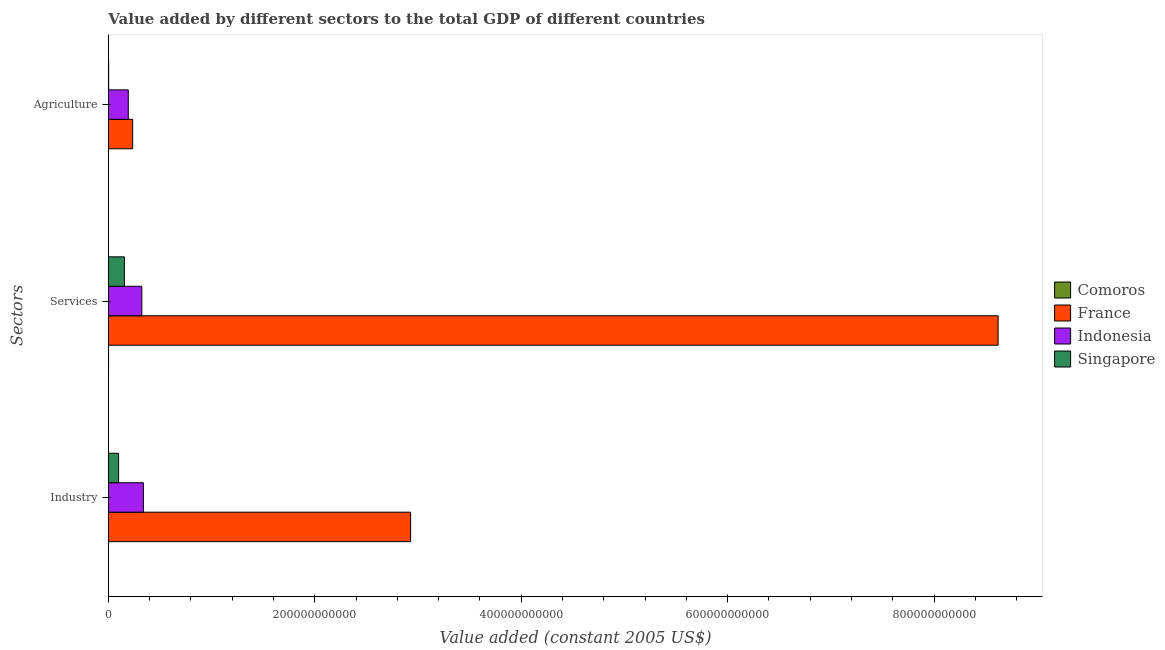How many different coloured bars are there?
Offer a very short reply. 4. Are the number of bars per tick equal to the number of legend labels?
Your response must be concise. Yes. What is the label of the 3rd group of bars from the top?
Provide a short and direct response. Industry. What is the value added by services in Indonesia?
Your answer should be very brief. 3.24e+1. Across all countries, what is the maximum value added by services?
Give a very brief answer. 8.62e+11. Across all countries, what is the minimum value added by industrial sector?
Provide a short and direct response. 3.03e+07. In which country was the value added by agricultural sector maximum?
Offer a very short reply. France. In which country was the value added by agricultural sector minimum?
Keep it short and to the point. Comoros. What is the total value added by industrial sector in the graph?
Provide a short and direct response. 3.37e+11. What is the difference between the value added by industrial sector in Indonesia and that in France?
Offer a terse response. -2.59e+11. What is the difference between the value added by industrial sector in Comoros and the value added by agricultural sector in Indonesia?
Your response must be concise. -1.92e+1. What is the average value added by industrial sector per country?
Provide a succinct answer. 8.41e+1. What is the difference between the value added by services and value added by industrial sector in Indonesia?
Your answer should be very brief. -1.52e+09. In how many countries, is the value added by services greater than 600000000000 US$?
Provide a succinct answer. 1. What is the ratio of the value added by agricultural sector in Indonesia to that in Comoros?
Provide a succinct answer. 274.52. Is the value added by agricultural sector in France less than that in Singapore?
Your answer should be compact. No. What is the difference between the highest and the second highest value added by industrial sector?
Offer a very short reply. 2.59e+11. What is the difference between the highest and the lowest value added by industrial sector?
Provide a succinct answer. 2.93e+11. In how many countries, is the value added by industrial sector greater than the average value added by industrial sector taken over all countries?
Your answer should be very brief. 1. What does the 4th bar from the top in Agriculture represents?
Ensure brevity in your answer.  Comoros. Is it the case that in every country, the sum of the value added by industrial sector and value added by services is greater than the value added by agricultural sector?
Your answer should be compact. Yes. How many bars are there?
Provide a succinct answer. 12. Are all the bars in the graph horizontal?
Your answer should be compact. Yes. How many countries are there in the graph?
Give a very brief answer. 4. What is the difference between two consecutive major ticks on the X-axis?
Offer a very short reply. 2.00e+11. Are the values on the major ticks of X-axis written in scientific E-notation?
Your response must be concise. No. Does the graph contain any zero values?
Offer a very short reply. No. How many legend labels are there?
Offer a very short reply. 4. How are the legend labels stacked?
Make the answer very short. Vertical. What is the title of the graph?
Your answer should be compact. Value added by different sectors to the total GDP of different countries. Does "Kuwait" appear as one of the legend labels in the graph?
Keep it short and to the point. No. What is the label or title of the X-axis?
Your response must be concise. Value added (constant 2005 US$). What is the label or title of the Y-axis?
Keep it short and to the point. Sectors. What is the Value added (constant 2005 US$) of Comoros in Industry?
Provide a succinct answer. 3.03e+07. What is the Value added (constant 2005 US$) of France in Industry?
Your answer should be compact. 2.93e+11. What is the Value added (constant 2005 US$) in Indonesia in Industry?
Your answer should be very brief. 3.39e+1. What is the Value added (constant 2005 US$) in Singapore in Industry?
Keep it short and to the point. 9.84e+09. What is the Value added (constant 2005 US$) of Comoros in Services?
Your answer should be very brief. 1.21e+08. What is the Value added (constant 2005 US$) in France in Services?
Your response must be concise. 8.62e+11. What is the Value added (constant 2005 US$) of Indonesia in Services?
Your answer should be compact. 3.24e+1. What is the Value added (constant 2005 US$) in Singapore in Services?
Your response must be concise. 1.54e+1. What is the Value added (constant 2005 US$) in Comoros in Agriculture?
Your answer should be very brief. 7.01e+07. What is the Value added (constant 2005 US$) of France in Agriculture?
Your answer should be very brief. 2.35e+1. What is the Value added (constant 2005 US$) in Indonesia in Agriculture?
Your answer should be compact. 1.92e+1. What is the Value added (constant 2005 US$) of Singapore in Agriculture?
Give a very brief answer. 2.40e+08. Across all Sectors, what is the maximum Value added (constant 2005 US$) of Comoros?
Offer a very short reply. 1.21e+08. Across all Sectors, what is the maximum Value added (constant 2005 US$) of France?
Your answer should be compact. 8.62e+11. Across all Sectors, what is the maximum Value added (constant 2005 US$) in Indonesia?
Provide a succinct answer. 3.39e+1. Across all Sectors, what is the maximum Value added (constant 2005 US$) of Singapore?
Provide a short and direct response. 1.54e+1. Across all Sectors, what is the minimum Value added (constant 2005 US$) of Comoros?
Give a very brief answer. 3.03e+07. Across all Sectors, what is the minimum Value added (constant 2005 US$) in France?
Provide a succinct answer. 2.35e+1. Across all Sectors, what is the minimum Value added (constant 2005 US$) in Indonesia?
Ensure brevity in your answer.  1.92e+1. Across all Sectors, what is the minimum Value added (constant 2005 US$) of Singapore?
Provide a succinct answer. 2.40e+08. What is the total Value added (constant 2005 US$) in Comoros in the graph?
Provide a short and direct response. 2.22e+08. What is the total Value added (constant 2005 US$) of France in the graph?
Offer a very short reply. 1.18e+12. What is the total Value added (constant 2005 US$) of Indonesia in the graph?
Provide a succinct answer. 8.55e+1. What is the total Value added (constant 2005 US$) of Singapore in the graph?
Offer a terse response. 2.55e+1. What is the difference between the Value added (constant 2005 US$) of Comoros in Industry and that in Services?
Provide a succinct answer. -9.12e+07. What is the difference between the Value added (constant 2005 US$) of France in Industry and that in Services?
Offer a very short reply. -5.69e+11. What is the difference between the Value added (constant 2005 US$) in Indonesia in Industry and that in Services?
Provide a succinct answer. 1.52e+09. What is the difference between the Value added (constant 2005 US$) in Singapore in Industry and that in Services?
Provide a short and direct response. -5.60e+09. What is the difference between the Value added (constant 2005 US$) in Comoros in Industry and that in Agriculture?
Provide a succinct answer. -3.98e+07. What is the difference between the Value added (constant 2005 US$) in France in Industry and that in Agriculture?
Offer a very short reply. 2.69e+11. What is the difference between the Value added (constant 2005 US$) in Indonesia in Industry and that in Agriculture?
Make the answer very short. 1.46e+1. What is the difference between the Value added (constant 2005 US$) in Singapore in Industry and that in Agriculture?
Provide a short and direct response. 9.60e+09. What is the difference between the Value added (constant 2005 US$) of Comoros in Services and that in Agriculture?
Give a very brief answer. 5.14e+07. What is the difference between the Value added (constant 2005 US$) of France in Services and that in Agriculture?
Provide a succinct answer. 8.39e+11. What is the difference between the Value added (constant 2005 US$) in Indonesia in Services and that in Agriculture?
Provide a short and direct response. 1.31e+1. What is the difference between the Value added (constant 2005 US$) of Singapore in Services and that in Agriculture?
Provide a short and direct response. 1.52e+1. What is the difference between the Value added (constant 2005 US$) of Comoros in Industry and the Value added (constant 2005 US$) of France in Services?
Your answer should be compact. -8.62e+11. What is the difference between the Value added (constant 2005 US$) in Comoros in Industry and the Value added (constant 2005 US$) in Indonesia in Services?
Make the answer very short. -3.23e+1. What is the difference between the Value added (constant 2005 US$) of Comoros in Industry and the Value added (constant 2005 US$) of Singapore in Services?
Provide a succinct answer. -1.54e+1. What is the difference between the Value added (constant 2005 US$) of France in Industry and the Value added (constant 2005 US$) of Indonesia in Services?
Your response must be concise. 2.60e+11. What is the difference between the Value added (constant 2005 US$) of France in Industry and the Value added (constant 2005 US$) of Singapore in Services?
Provide a short and direct response. 2.77e+11. What is the difference between the Value added (constant 2005 US$) in Indonesia in Industry and the Value added (constant 2005 US$) in Singapore in Services?
Provide a succinct answer. 1.84e+1. What is the difference between the Value added (constant 2005 US$) in Comoros in Industry and the Value added (constant 2005 US$) in France in Agriculture?
Your answer should be very brief. -2.35e+1. What is the difference between the Value added (constant 2005 US$) of Comoros in Industry and the Value added (constant 2005 US$) of Indonesia in Agriculture?
Make the answer very short. -1.92e+1. What is the difference between the Value added (constant 2005 US$) in Comoros in Industry and the Value added (constant 2005 US$) in Singapore in Agriculture?
Provide a succinct answer. -2.10e+08. What is the difference between the Value added (constant 2005 US$) of France in Industry and the Value added (constant 2005 US$) of Indonesia in Agriculture?
Offer a terse response. 2.74e+11. What is the difference between the Value added (constant 2005 US$) of France in Industry and the Value added (constant 2005 US$) of Singapore in Agriculture?
Make the answer very short. 2.93e+11. What is the difference between the Value added (constant 2005 US$) in Indonesia in Industry and the Value added (constant 2005 US$) in Singapore in Agriculture?
Give a very brief answer. 3.36e+1. What is the difference between the Value added (constant 2005 US$) in Comoros in Services and the Value added (constant 2005 US$) in France in Agriculture?
Your response must be concise. -2.34e+1. What is the difference between the Value added (constant 2005 US$) in Comoros in Services and the Value added (constant 2005 US$) in Indonesia in Agriculture?
Your answer should be compact. -1.91e+1. What is the difference between the Value added (constant 2005 US$) in Comoros in Services and the Value added (constant 2005 US$) in Singapore in Agriculture?
Ensure brevity in your answer.  -1.19e+08. What is the difference between the Value added (constant 2005 US$) of France in Services and the Value added (constant 2005 US$) of Indonesia in Agriculture?
Give a very brief answer. 8.43e+11. What is the difference between the Value added (constant 2005 US$) of France in Services and the Value added (constant 2005 US$) of Singapore in Agriculture?
Your answer should be compact. 8.62e+11. What is the difference between the Value added (constant 2005 US$) of Indonesia in Services and the Value added (constant 2005 US$) of Singapore in Agriculture?
Your response must be concise. 3.21e+1. What is the average Value added (constant 2005 US$) of Comoros per Sectors?
Offer a very short reply. 7.40e+07. What is the average Value added (constant 2005 US$) in France per Sectors?
Keep it short and to the point. 3.93e+11. What is the average Value added (constant 2005 US$) in Indonesia per Sectors?
Offer a terse response. 2.85e+1. What is the average Value added (constant 2005 US$) of Singapore per Sectors?
Your response must be concise. 8.51e+09. What is the difference between the Value added (constant 2005 US$) of Comoros and Value added (constant 2005 US$) of France in Industry?
Make the answer very short. -2.93e+11. What is the difference between the Value added (constant 2005 US$) of Comoros and Value added (constant 2005 US$) of Indonesia in Industry?
Ensure brevity in your answer.  -3.39e+1. What is the difference between the Value added (constant 2005 US$) of Comoros and Value added (constant 2005 US$) of Singapore in Industry?
Offer a very short reply. -9.81e+09. What is the difference between the Value added (constant 2005 US$) in France and Value added (constant 2005 US$) in Indonesia in Industry?
Your response must be concise. 2.59e+11. What is the difference between the Value added (constant 2005 US$) of France and Value added (constant 2005 US$) of Singapore in Industry?
Offer a very short reply. 2.83e+11. What is the difference between the Value added (constant 2005 US$) in Indonesia and Value added (constant 2005 US$) in Singapore in Industry?
Keep it short and to the point. 2.40e+1. What is the difference between the Value added (constant 2005 US$) in Comoros and Value added (constant 2005 US$) in France in Services?
Your response must be concise. -8.62e+11. What is the difference between the Value added (constant 2005 US$) of Comoros and Value added (constant 2005 US$) of Indonesia in Services?
Offer a very short reply. -3.22e+1. What is the difference between the Value added (constant 2005 US$) in Comoros and Value added (constant 2005 US$) in Singapore in Services?
Offer a terse response. -1.53e+1. What is the difference between the Value added (constant 2005 US$) of France and Value added (constant 2005 US$) of Indonesia in Services?
Ensure brevity in your answer.  8.30e+11. What is the difference between the Value added (constant 2005 US$) of France and Value added (constant 2005 US$) of Singapore in Services?
Your answer should be compact. 8.47e+11. What is the difference between the Value added (constant 2005 US$) in Indonesia and Value added (constant 2005 US$) in Singapore in Services?
Your response must be concise. 1.69e+1. What is the difference between the Value added (constant 2005 US$) of Comoros and Value added (constant 2005 US$) of France in Agriculture?
Ensure brevity in your answer.  -2.34e+1. What is the difference between the Value added (constant 2005 US$) in Comoros and Value added (constant 2005 US$) in Indonesia in Agriculture?
Provide a succinct answer. -1.92e+1. What is the difference between the Value added (constant 2005 US$) in Comoros and Value added (constant 2005 US$) in Singapore in Agriculture?
Your response must be concise. -1.70e+08. What is the difference between the Value added (constant 2005 US$) in France and Value added (constant 2005 US$) in Indonesia in Agriculture?
Your answer should be very brief. 4.25e+09. What is the difference between the Value added (constant 2005 US$) in France and Value added (constant 2005 US$) in Singapore in Agriculture?
Provide a short and direct response. 2.33e+1. What is the difference between the Value added (constant 2005 US$) in Indonesia and Value added (constant 2005 US$) in Singapore in Agriculture?
Keep it short and to the point. 1.90e+1. What is the ratio of the Value added (constant 2005 US$) of Comoros in Industry to that in Services?
Your answer should be compact. 0.25. What is the ratio of the Value added (constant 2005 US$) of France in Industry to that in Services?
Ensure brevity in your answer.  0.34. What is the ratio of the Value added (constant 2005 US$) of Indonesia in Industry to that in Services?
Keep it short and to the point. 1.05. What is the ratio of the Value added (constant 2005 US$) in Singapore in Industry to that in Services?
Make the answer very short. 0.64. What is the ratio of the Value added (constant 2005 US$) in Comoros in Industry to that in Agriculture?
Give a very brief answer. 0.43. What is the ratio of the Value added (constant 2005 US$) of France in Industry to that in Agriculture?
Keep it short and to the point. 12.47. What is the ratio of the Value added (constant 2005 US$) in Indonesia in Industry to that in Agriculture?
Ensure brevity in your answer.  1.76. What is the ratio of the Value added (constant 2005 US$) of Singapore in Industry to that in Agriculture?
Offer a terse response. 40.99. What is the ratio of the Value added (constant 2005 US$) of Comoros in Services to that in Agriculture?
Your answer should be compact. 1.73. What is the ratio of the Value added (constant 2005 US$) of France in Services to that in Agriculture?
Offer a very short reply. 36.7. What is the ratio of the Value added (constant 2005 US$) in Indonesia in Services to that in Agriculture?
Ensure brevity in your answer.  1.68. What is the ratio of the Value added (constant 2005 US$) of Singapore in Services to that in Agriculture?
Make the answer very short. 64.31. What is the difference between the highest and the second highest Value added (constant 2005 US$) of Comoros?
Offer a very short reply. 5.14e+07. What is the difference between the highest and the second highest Value added (constant 2005 US$) of France?
Your response must be concise. 5.69e+11. What is the difference between the highest and the second highest Value added (constant 2005 US$) of Indonesia?
Make the answer very short. 1.52e+09. What is the difference between the highest and the second highest Value added (constant 2005 US$) in Singapore?
Make the answer very short. 5.60e+09. What is the difference between the highest and the lowest Value added (constant 2005 US$) of Comoros?
Give a very brief answer. 9.12e+07. What is the difference between the highest and the lowest Value added (constant 2005 US$) in France?
Give a very brief answer. 8.39e+11. What is the difference between the highest and the lowest Value added (constant 2005 US$) of Indonesia?
Your answer should be very brief. 1.46e+1. What is the difference between the highest and the lowest Value added (constant 2005 US$) in Singapore?
Your answer should be very brief. 1.52e+1. 